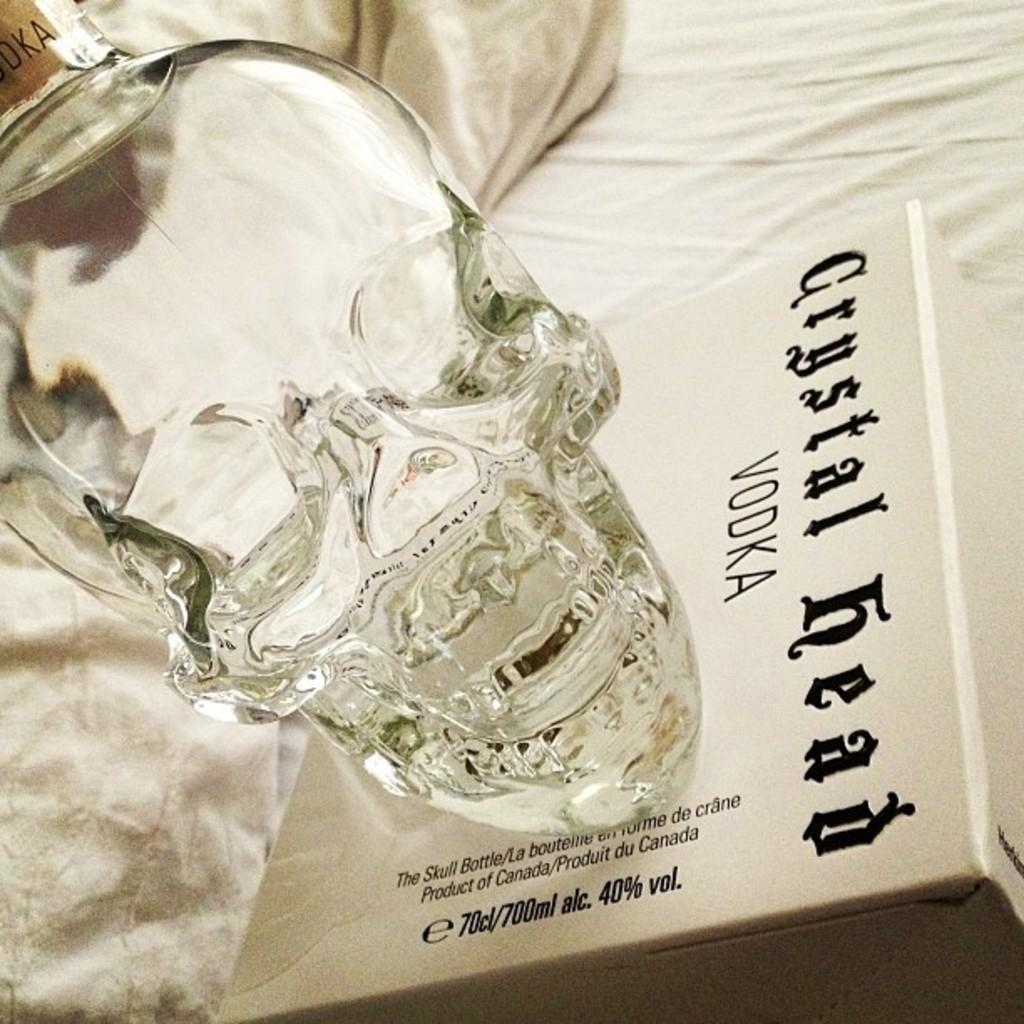Provide a one-sentence caption for the provided image. A bottle of Crystal Head vodka is shaped like a crystal head. 